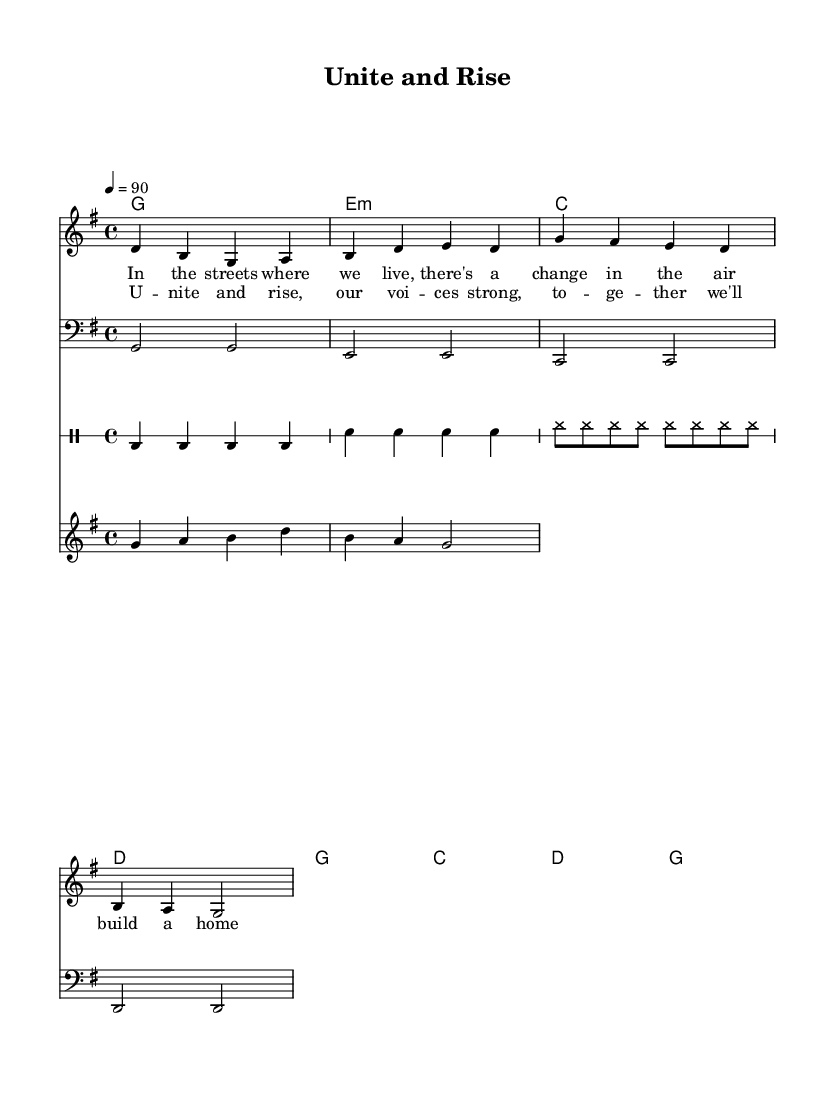What is the key signature of this music? The key signature is G major, which has one sharp note (F#).
Answer: G major What is the time signature of this music? The time signature is 4/4, indicating four beats per measure.
Answer: 4/4 What is the tempo marking of the piece? The tempo marking indicates a speed of 90 beats per minute.
Answer: 90 How many measures are there in the chorus section? The chorus consists of four measures, as indicated by the grouping of bars in the score.
Answer: 4 What phrase describes the primary theme of the song? The song's theme centers around empowerment and community building, as reflected in the lyrics provided.
Answer: Empowerment and community What is the role of the bass line in reggae music? The bass line typically emphasizes the off-beats and provides a rhythmic foundation, which can be seen in the repetitive pattern in this score.
Answer: Rhythmic foundation How are the lyrics structured in this piece? The lyrics are structured into a verse and a chorus, clearly denoting a difference in thematic focus.
Answer: Verse and chorus 